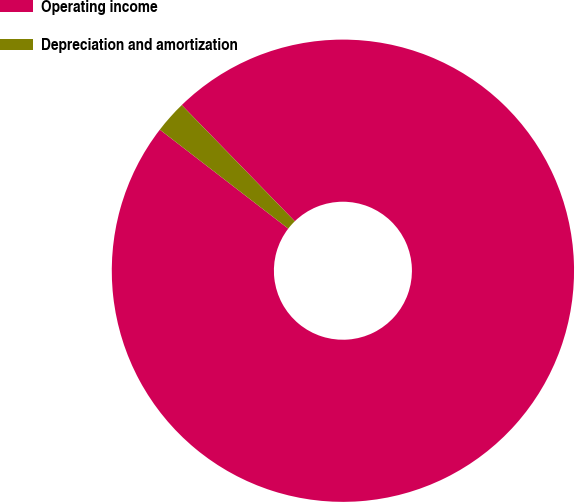<chart> <loc_0><loc_0><loc_500><loc_500><pie_chart><fcel>Operating income<fcel>Depreciation and amortization<nl><fcel>97.73%<fcel>2.27%<nl></chart> 